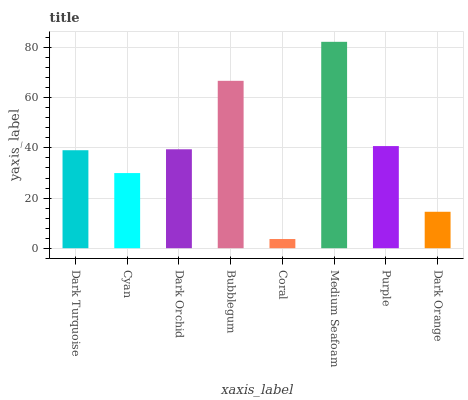Is Coral the minimum?
Answer yes or no. Yes. Is Medium Seafoam the maximum?
Answer yes or no. Yes. Is Cyan the minimum?
Answer yes or no. No. Is Cyan the maximum?
Answer yes or no. No. Is Dark Turquoise greater than Cyan?
Answer yes or no. Yes. Is Cyan less than Dark Turquoise?
Answer yes or no. Yes. Is Cyan greater than Dark Turquoise?
Answer yes or no. No. Is Dark Turquoise less than Cyan?
Answer yes or no. No. Is Dark Orchid the high median?
Answer yes or no. Yes. Is Dark Turquoise the low median?
Answer yes or no. Yes. Is Bubblegum the high median?
Answer yes or no. No. Is Bubblegum the low median?
Answer yes or no. No. 